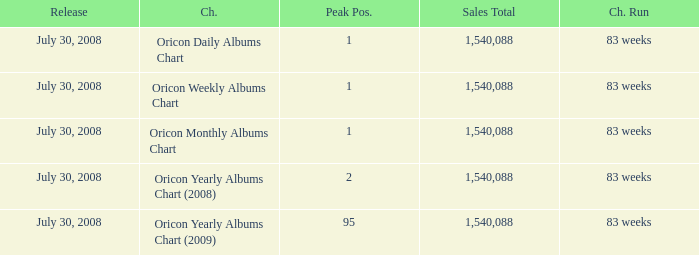Write the full table. {'header': ['Release', 'Ch.', 'Peak Pos.', 'Sales Total', 'Ch. Run'], 'rows': [['July 30, 2008', 'Oricon Daily Albums Chart', '1', '1,540,088', '83 weeks'], ['July 30, 2008', 'Oricon Weekly Albums Chart', '1', '1,540,088', '83 weeks'], ['July 30, 2008', 'Oricon Monthly Albums Chart', '1', '1,540,088', '83 weeks'], ['July 30, 2008', 'Oricon Yearly Albums Chart (2008)', '2', '1,540,088', '83 weeks'], ['July 30, 2008', 'Oricon Yearly Albums Chart (2009)', '95', '1,540,088', '83 weeks']]} How much Peak Position has Sales Total larger than 1,540,088? 0.0. 